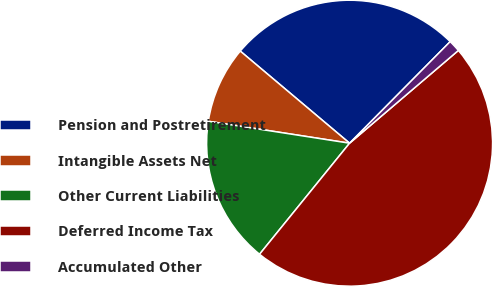Convert chart. <chart><loc_0><loc_0><loc_500><loc_500><pie_chart><fcel>Pension and Postretirement<fcel>Intangible Assets Net<fcel>Other Current Liabilities<fcel>Deferred Income Tax<fcel>Accumulated Other<nl><fcel>26.28%<fcel>8.69%<fcel>16.61%<fcel>47.08%<fcel>1.34%<nl></chart> 